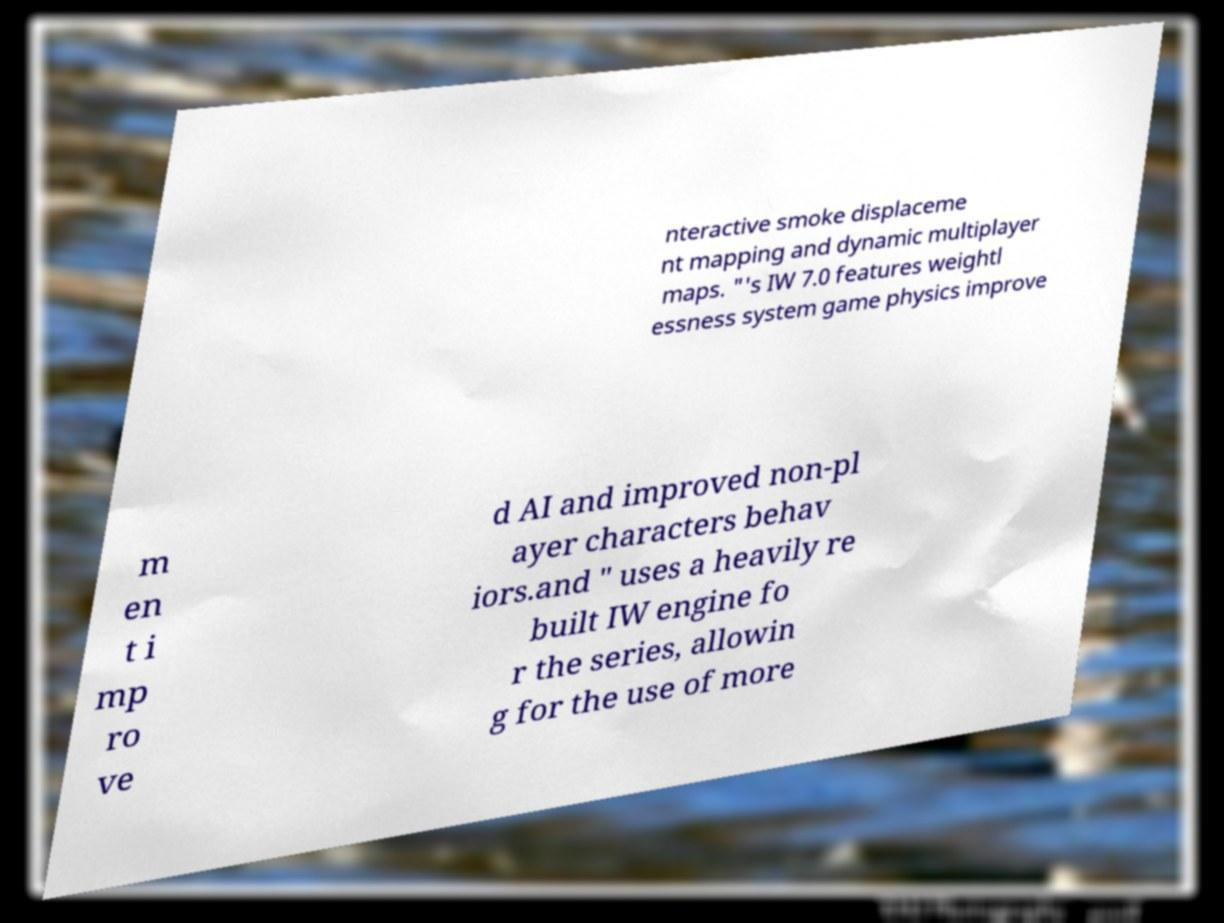Please read and relay the text visible in this image. What does it say? nteractive smoke displaceme nt mapping and dynamic multiplayer maps. "'s IW 7.0 features weightl essness system game physics improve m en t i mp ro ve d AI and improved non-pl ayer characters behav iors.and " uses a heavily re built IW engine fo r the series, allowin g for the use of more 